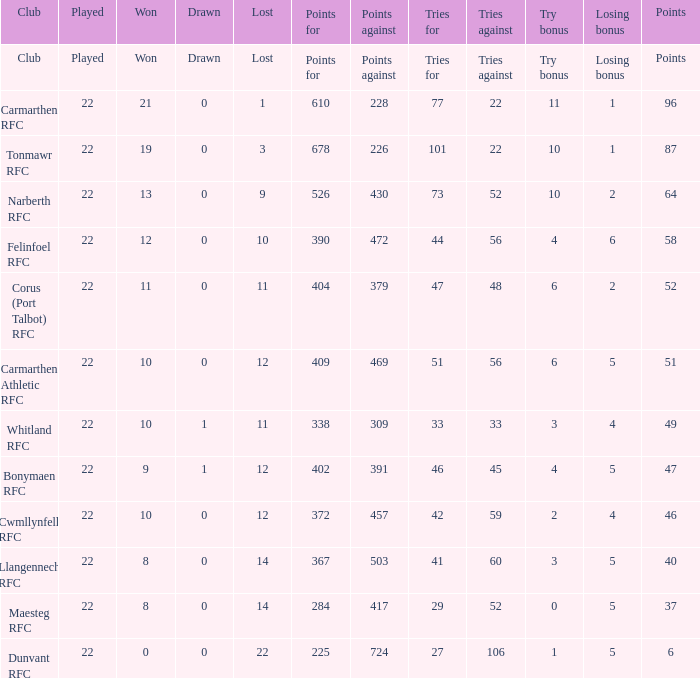Name the tries against for 87 points 22.0. 